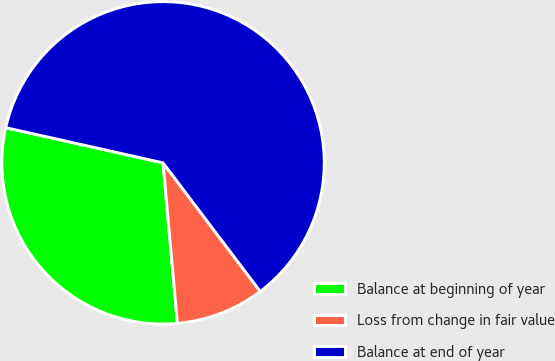Convert chart. <chart><loc_0><loc_0><loc_500><loc_500><pie_chart><fcel>Balance at beginning of year<fcel>Loss from change in fair value<fcel>Balance at end of year<nl><fcel>29.92%<fcel>8.88%<fcel>61.2%<nl></chart> 